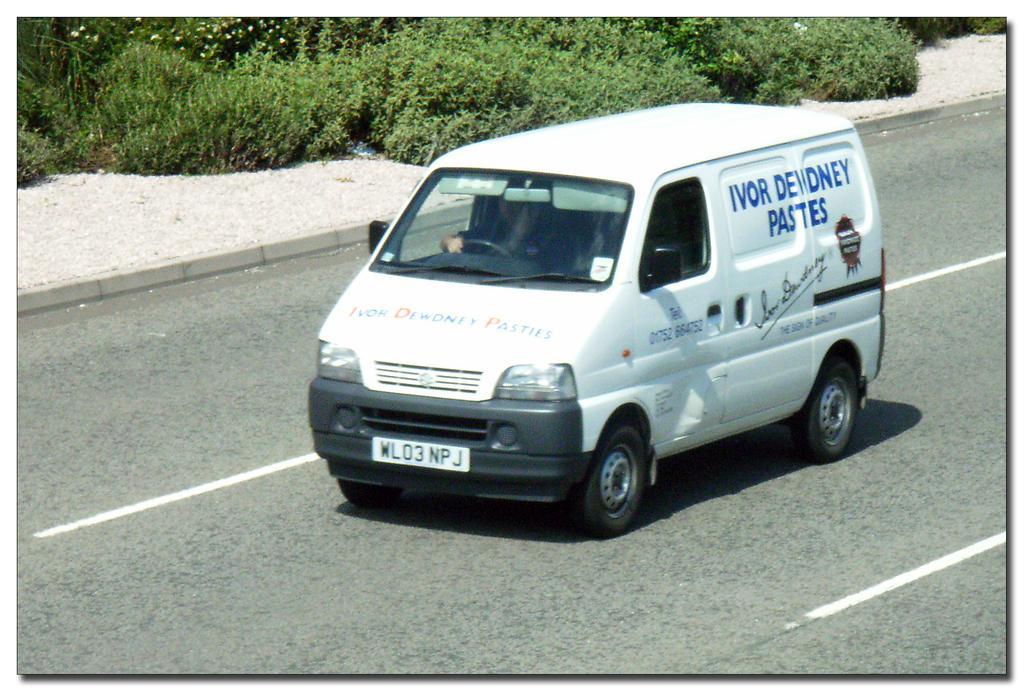In one or two sentences, can you explain what this image depicts? In this picture we can see a vehicle on the road with a person sitting inside it and in the background we can see trees. 